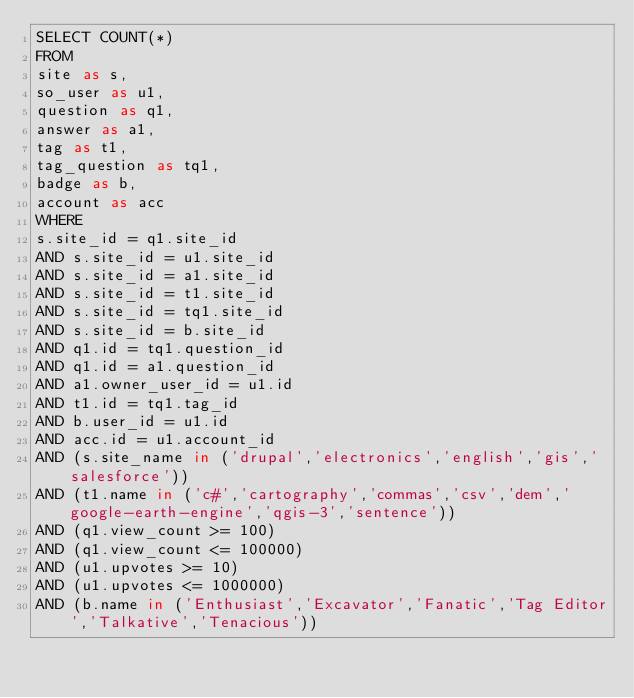<code> <loc_0><loc_0><loc_500><loc_500><_SQL_>SELECT COUNT(*)
FROM
site as s,
so_user as u1,
question as q1,
answer as a1,
tag as t1,
tag_question as tq1,
badge as b,
account as acc
WHERE
s.site_id = q1.site_id
AND s.site_id = u1.site_id
AND s.site_id = a1.site_id
AND s.site_id = t1.site_id
AND s.site_id = tq1.site_id
AND s.site_id = b.site_id
AND q1.id = tq1.question_id
AND q1.id = a1.question_id
AND a1.owner_user_id = u1.id
AND t1.id = tq1.tag_id
AND b.user_id = u1.id
AND acc.id = u1.account_id
AND (s.site_name in ('drupal','electronics','english','gis','salesforce'))
AND (t1.name in ('c#','cartography','commas','csv','dem','google-earth-engine','qgis-3','sentence'))
AND (q1.view_count >= 100)
AND (q1.view_count <= 100000)
AND (u1.upvotes >= 10)
AND (u1.upvotes <= 1000000)
AND (b.name in ('Enthusiast','Excavator','Fanatic','Tag Editor','Talkative','Tenacious'))
</code> 